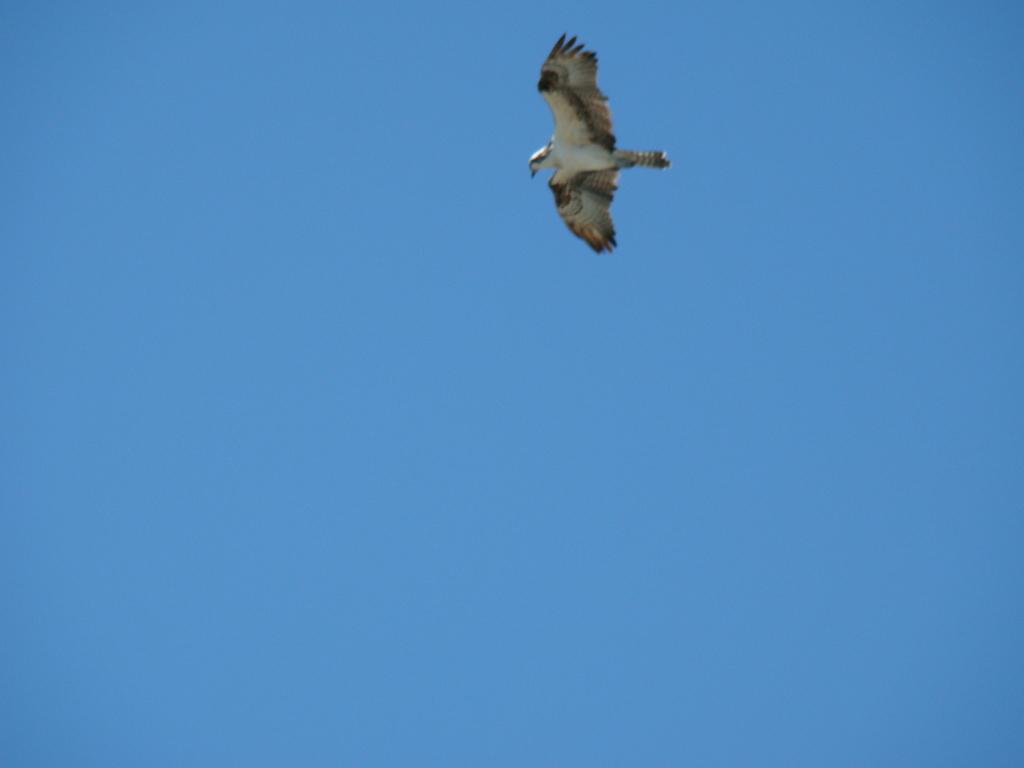What type of animal is in the image? There is a bird in the image. What is the bird doing in the image? The bird is flying in the air. Can you describe the coloration of the bird? The bird has white and black coloration. What can be seen in the background of the image? There is a sky visible in the background of the image. How many cattle can be seen grazing on the road in the image? There are no cattle or roads present in the image; it features a bird flying in the sky. 